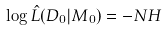<formula> <loc_0><loc_0><loc_500><loc_500>\log \hat { L } ( D _ { 0 } | M _ { 0 } ) = - N H</formula> 